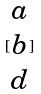Convert formula to latex. <formula><loc_0><loc_0><loc_500><loc_500>[ \begin{matrix} a \\ b \\ d \end{matrix} ]</formula> 